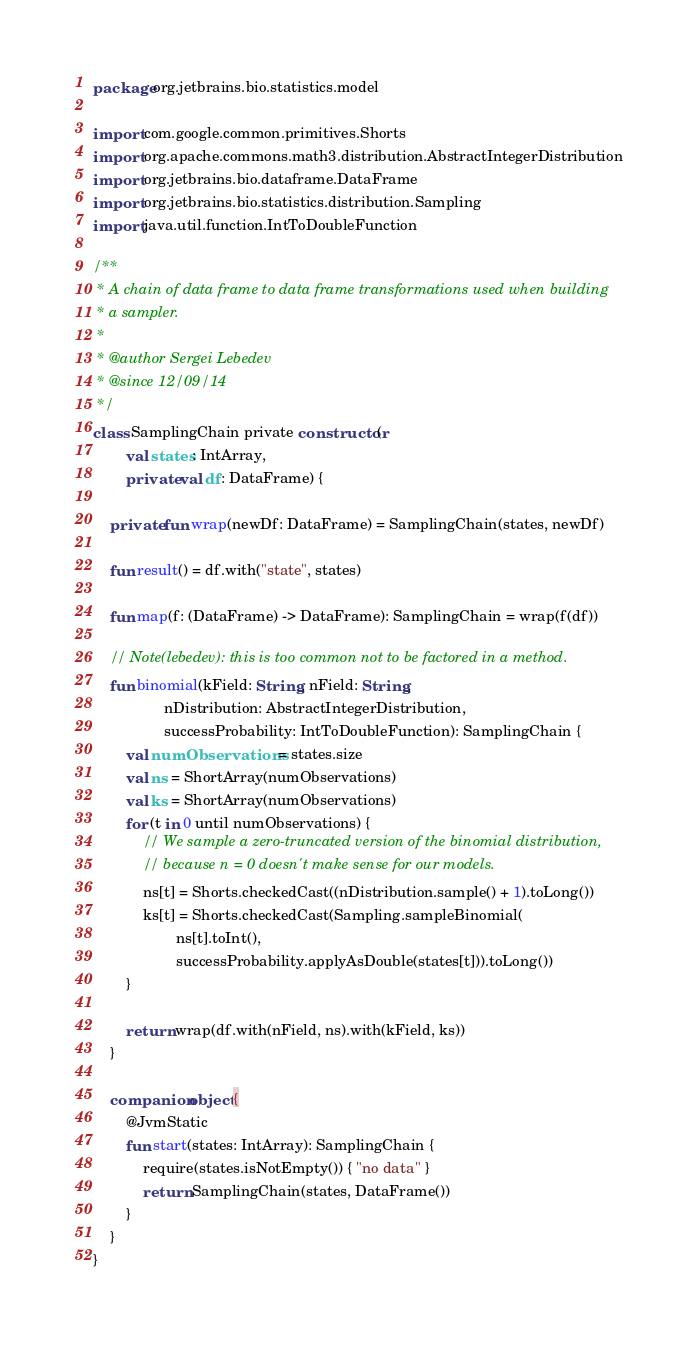Convert code to text. <code><loc_0><loc_0><loc_500><loc_500><_Kotlin_>package org.jetbrains.bio.statistics.model

import com.google.common.primitives.Shorts
import org.apache.commons.math3.distribution.AbstractIntegerDistribution
import org.jetbrains.bio.dataframe.DataFrame
import org.jetbrains.bio.statistics.distribution.Sampling
import java.util.function.IntToDoubleFunction

/**
 * A chain of data frame to data frame transformations used when building
 * a sampler.
 *
 * @author Sergei Lebedev
 * @since 12/09/14
 */
class SamplingChain private constructor(
        val states: IntArray,
        private val df: DataFrame) {

    private fun wrap(newDf: DataFrame) = SamplingChain(states, newDf)

    fun result() = df.with("state", states)

    fun map(f: (DataFrame) -> DataFrame): SamplingChain = wrap(f(df))

    // Note(lebedev): this is too common not to be factored in a method.
    fun binomial(kField: String, nField: String,
                 nDistribution: AbstractIntegerDistribution,
                 successProbability: IntToDoubleFunction): SamplingChain {
        val numObservations = states.size
        val ns = ShortArray(numObservations)
        val ks = ShortArray(numObservations)
        for (t in 0 until numObservations) {
            // We sample a zero-truncated version of the binomial distribution,
            // because n = 0 doesn't make sense for our models.
            ns[t] = Shorts.checkedCast((nDistribution.sample() + 1).toLong())
            ks[t] = Shorts.checkedCast(Sampling.sampleBinomial(
                    ns[t].toInt(),
                    successProbability.applyAsDouble(states[t])).toLong())
        }

        return wrap(df.with(nField, ns).with(kField, ks))
    }

    companion object {
        @JvmStatic
        fun start(states: IntArray): SamplingChain {
            require(states.isNotEmpty()) { "no data" }
            return SamplingChain(states, DataFrame())
        }
    }
}</code> 